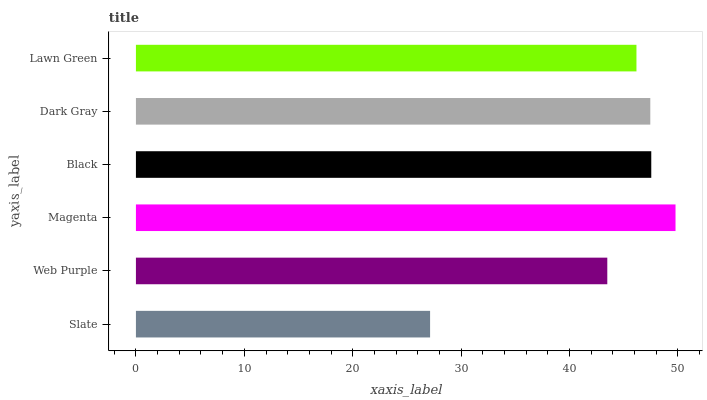Is Slate the minimum?
Answer yes or no. Yes. Is Magenta the maximum?
Answer yes or no. Yes. Is Web Purple the minimum?
Answer yes or no. No. Is Web Purple the maximum?
Answer yes or no. No. Is Web Purple greater than Slate?
Answer yes or no. Yes. Is Slate less than Web Purple?
Answer yes or no. Yes. Is Slate greater than Web Purple?
Answer yes or no. No. Is Web Purple less than Slate?
Answer yes or no. No. Is Dark Gray the high median?
Answer yes or no. Yes. Is Lawn Green the low median?
Answer yes or no. Yes. Is Lawn Green the high median?
Answer yes or no. No. Is Web Purple the low median?
Answer yes or no. No. 